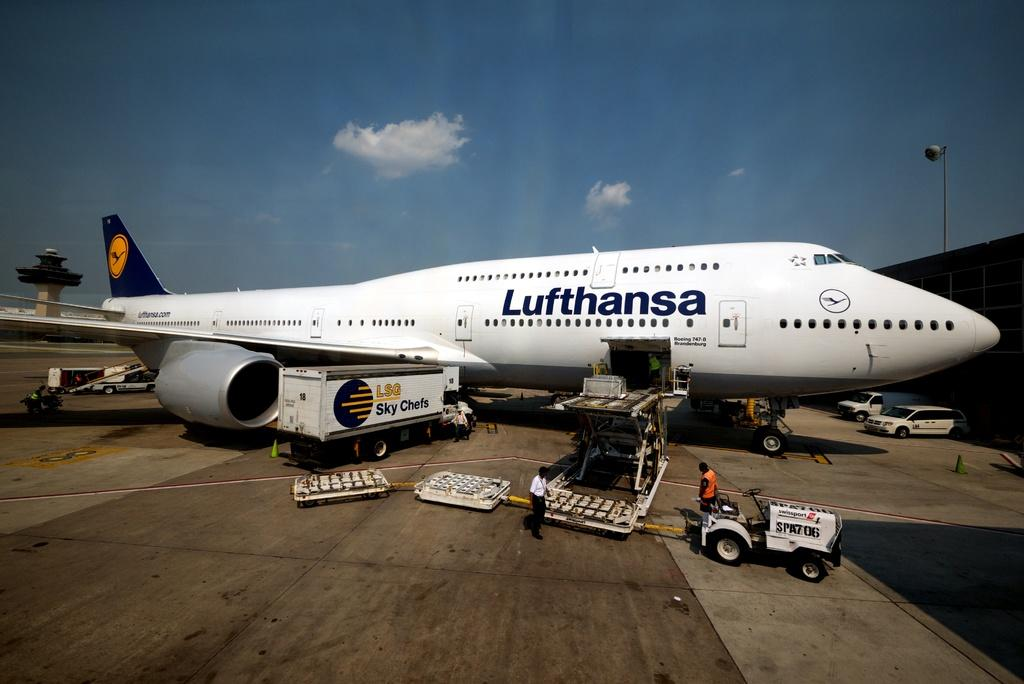<image>
Share a concise interpretation of the image provided. A large airplane with the word Lufthansa across it 